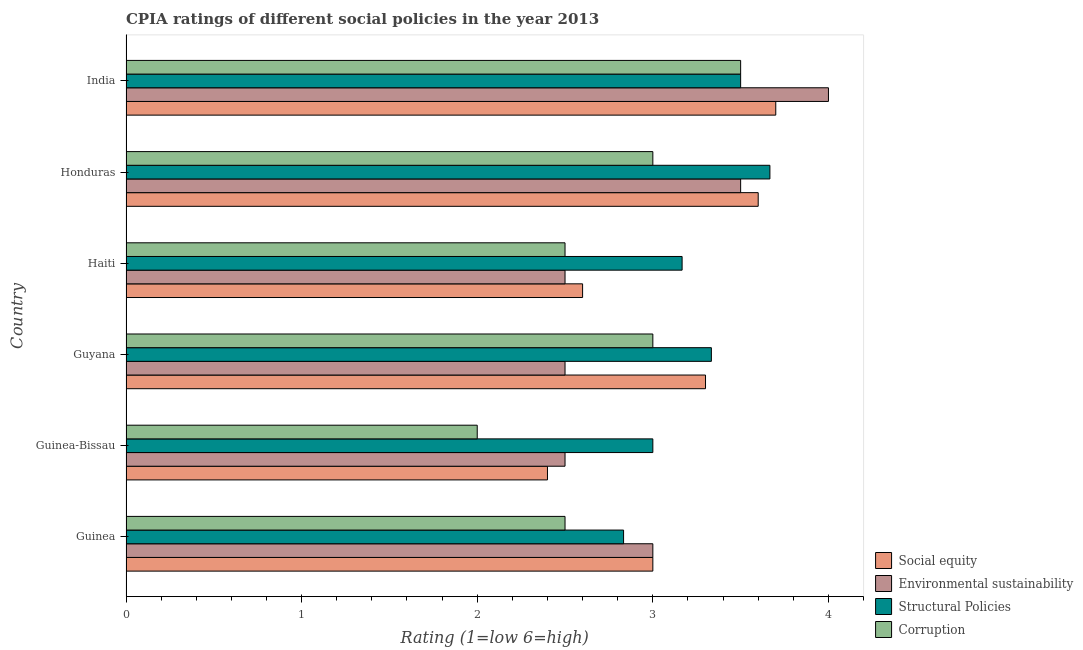How many groups of bars are there?
Offer a terse response. 6. Are the number of bars per tick equal to the number of legend labels?
Provide a short and direct response. Yes. Are the number of bars on each tick of the Y-axis equal?
Provide a short and direct response. Yes. How many bars are there on the 4th tick from the top?
Your answer should be compact. 4. How many bars are there on the 6th tick from the bottom?
Keep it short and to the point. 4. What is the cpia rating of environmental sustainability in Guinea-Bissau?
Your answer should be compact. 2.5. Across all countries, what is the maximum cpia rating of structural policies?
Your answer should be compact. 3.67. Across all countries, what is the minimum cpia rating of social equity?
Offer a very short reply. 2.4. In which country was the cpia rating of environmental sustainability maximum?
Ensure brevity in your answer.  India. In which country was the cpia rating of social equity minimum?
Offer a very short reply. Guinea-Bissau. What is the total cpia rating of social equity in the graph?
Give a very brief answer. 18.6. What is the difference between the cpia rating of structural policies in Haiti and the cpia rating of environmental sustainability in India?
Your answer should be compact. -0.83. What is the average cpia rating of structural policies per country?
Offer a very short reply. 3.25. What is the ratio of the cpia rating of social equity in Guinea to that in Honduras?
Provide a succinct answer. 0.83. Is the cpia rating of social equity in Guyana less than that in Honduras?
Offer a very short reply. Yes. Is the difference between the cpia rating of environmental sustainability in Guinea and India greater than the difference between the cpia rating of structural policies in Guinea and India?
Your answer should be very brief. No. What is the difference between the highest and the second highest cpia rating of social equity?
Offer a very short reply. 0.1. What is the difference between the highest and the lowest cpia rating of corruption?
Make the answer very short. 1.5. What does the 4th bar from the top in Guinea-Bissau represents?
Your answer should be compact. Social equity. What does the 2nd bar from the bottom in Guinea-Bissau represents?
Keep it short and to the point. Environmental sustainability. Is it the case that in every country, the sum of the cpia rating of social equity and cpia rating of environmental sustainability is greater than the cpia rating of structural policies?
Offer a very short reply. Yes. Are all the bars in the graph horizontal?
Provide a succinct answer. Yes. How many countries are there in the graph?
Your response must be concise. 6. Are the values on the major ticks of X-axis written in scientific E-notation?
Provide a short and direct response. No. Does the graph contain grids?
Give a very brief answer. No. Where does the legend appear in the graph?
Keep it short and to the point. Bottom right. How many legend labels are there?
Give a very brief answer. 4. How are the legend labels stacked?
Give a very brief answer. Vertical. What is the title of the graph?
Keep it short and to the point. CPIA ratings of different social policies in the year 2013. Does "UNRWA" appear as one of the legend labels in the graph?
Make the answer very short. No. What is the label or title of the X-axis?
Give a very brief answer. Rating (1=low 6=high). What is the label or title of the Y-axis?
Give a very brief answer. Country. What is the Rating (1=low 6=high) of Environmental sustainability in Guinea?
Provide a short and direct response. 3. What is the Rating (1=low 6=high) of Structural Policies in Guinea?
Offer a very short reply. 2.83. What is the Rating (1=low 6=high) in Social equity in Guinea-Bissau?
Ensure brevity in your answer.  2.4. What is the Rating (1=low 6=high) of Social equity in Guyana?
Give a very brief answer. 3.3. What is the Rating (1=low 6=high) in Environmental sustainability in Guyana?
Provide a succinct answer. 2.5. What is the Rating (1=low 6=high) in Structural Policies in Guyana?
Your answer should be very brief. 3.33. What is the Rating (1=low 6=high) of Structural Policies in Haiti?
Provide a succinct answer. 3.17. What is the Rating (1=low 6=high) of Corruption in Haiti?
Your answer should be compact. 2.5. What is the Rating (1=low 6=high) in Social equity in Honduras?
Make the answer very short. 3.6. What is the Rating (1=low 6=high) in Structural Policies in Honduras?
Your response must be concise. 3.67. What is the Rating (1=low 6=high) in Corruption in Honduras?
Make the answer very short. 3. What is the Rating (1=low 6=high) of Corruption in India?
Your response must be concise. 3.5. Across all countries, what is the maximum Rating (1=low 6=high) in Environmental sustainability?
Make the answer very short. 4. Across all countries, what is the maximum Rating (1=low 6=high) of Structural Policies?
Provide a short and direct response. 3.67. Across all countries, what is the minimum Rating (1=low 6=high) in Environmental sustainability?
Give a very brief answer. 2.5. Across all countries, what is the minimum Rating (1=low 6=high) of Structural Policies?
Your answer should be very brief. 2.83. Across all countries, what is the minimum Rating (1=low 6=high) in Corruption?
Your response must be concise. 2. What is the total Rating (1=low 6=high) in Environmental sustainability in the graph?
Your answer should be compact. 18. What is the total Rating (1=low 6=high) in Structural Policies in the graph?
Your answer should be very brief. 19.5. What is the total Rating (1=low 6=high) of Corruption in the graph?
Keep it short and to the point. 16.5. What is the difference between the Rating (1=low 6=high) of Social equity in Guinea and that in Guinea-Bissau?
Provide a succinct answer. 0.6. What is the difference between the Rating (1=low 6=high) in Social equity in Guinea and that in Guyana?
Ensure brevity in your answer.  -0.3. What is the difference between the Rating (1=low 6=high) in Structural Policies in Guinea and that in Guyana?
Provide a short and direct response. -0.5. What is the difference between the Rating (1=low 6=high) of Corruption in Guinea and that in Guyana?
Your answer should be very brief. -0.5. What is the difference between the Rating (1=low 6=high) of Social equity in Guinea and that in Haiti?
Your answer should be very brief. 0.4. What is the difference between the Rating (1=low 6=high) of Environmental sustainability in Guinea and that in Haiti?
Keep it short and to the point. 0.5. What is the difference between the Rating (1=low 6=high) in Structural Policies in Guinea and that in Haiti?
Your response must be concise. -0.33. What is the difference between the Rating (1=low 6=high) in Corruption in Guinea and that in Haiti?
Your answer should be compact. 0. What is the difference between the Rating (1=low 6=high) of Social equity in Guinea and that in India?
Provide a succinct answer. -0.7. What is the difference between the Rating (1=low 6=high) of Environmental sustainability in Guinea and that in India?
Provide a short and direct response. -1. What is the difference between the Rating (1=low 6=high) of Social equity in Guinea-Bissau and that in Guyana?
Provide a succinct answer. -0.9. What is the difference between the Rating (1=low 6=high) in Environmental sustainability in Guinea-Bissau and that in Guyana?
Provide a short and direct response. 0. What is the difference between the Rating (1=low 6=high) of Corruption in Guinea-Bissau and that in Guyana?
Your answer should be very brief. -1. What is the difference between the Rating (1=low 6=high) of Social equity in Guinea-Bissau and that in Haiti?
Offer a very short reply. -0.2. What is the difference between the Rating (1=low 6=high) of Environmental sustainability in Guinea-Bissau and that in Haiti?
Provide a succinct answer. 0. What is the difference between the Rating (1=low 6=high) in Corruption in Guinea-Bissau and that in Haiti?
Your answer should be very brief. -0.5. What is the difference between the Rating (1=low 6=high) of Environmental sustainability in Guinea-Bissau and that in Honduras?
Your response must be concise. -1. What is the difference between the Rating (1=low 6=high) in Structural Policies in Guinea-Bissau and that in Honduras?
Give a very brief answer. -0.67. What is the difference between the Rating (1=low 6=high) of Corruption in Guinea-Bissau and that in Honduras?
Provide a succinct answer. -1. What is the difference between the Rating (1=low 6=high) of Structural Policies in Guinea-Bissau and that in India?
Your response must be concise. -0.5. What is the difference between the Rating (1=low 6=high) of Social equity in Guyana and that in Haiti?
Give a very brief answer. 0.7. What is the difference between the Rating (1=low 6=high) of Structural Policies in Guyana and that in Haiti?
Provide a succinct answer. 0.17. What is the difference between the Rating (1=low 6=high) in Social equity in Guyana and that in Honduras?
Provide a short and direct response. -0.3. What is the difference between the Rating (1=low 6=high) of Environmental sustainability in Guyana and that in Honduras?
Provide a succinct answer. -1. What is the difference between the Rating (1=low 6=high) in Structural Policies in Guyana and that in Honduras?
Give a very brief answer. -0.33. What is the difference between the Rating (1=low 6=high) in Corruption in Guyana and that in Honduras?
Offer a very short reply. 0. What is the difference between the Rating (1=low 6=high) in Environmental sustainability in Guyana and that in India?
Ensure brevity in your answer.  -1.5. What is the difference between the Rating (1=low 6=high) in Structural Policies in Guyana and that in India?
Your response must be concise. -0.17. What is the difference between the Rating (1=low 6=high) in Corruption in Guyana and that in India?
Ensure brevity in your answer.  -0.5. What is the difference between the Rating (1=low 6=high) in Corruption in Haiti and that in Honduras?
Your answer should be very brief. -0.5. What is the difference between the Rating (1=low 6=high) in Social equity in Haiti and that in India?
Provide a succinct answer. -1.1. What is the difference between the Rating (1=low 6=high) of Structural Policies in Haiti and that in India?
Offer a terse response. -0.33. What is the difference between the Rating (1=low 6=high) in Corruption in Haiti and that in India?
Your response must be concise. -1. What is the difference between the Rating (1=low 6=high) of Social equity in Guinea and the Rating (1=low 6=high) of Environmental sustainability in Guinea-Bissau?
Ensure brevity in your answer.  0.5. What is the difference between the Rating (1=low 6=high) in Environmental sustainability in Guinea and the Rating (1=low 6=high) in Structural Policies in Guinea-Bissau?
Offer a terse response. 0. What is the difference between the Rating (1=low 6=high) of Structural Policies in Guinea and the Rating (1=low 6=high) of Corruption in Guinea-Bissau?
Keep it short and to the point. 0.83. What is the difference between the Rating (1=low 6=high) of Social equity in Guinea and the Rating (1=low 6=high) of Structural Policies in Guyana?
Ensure brevity in your answer.  -0.33. What is the difference between the Rating (1=low 6=high) of Social equity in Guinea and the Rating (1=low 6=high) of Corruption in Guyana?
Offer a very short reply. 0. What is the difference between the Rating (1=low 6=high) in Environmental sustainability in Guinea and the Rating (1=low 6=high) in Corruption in Guyana?
Offer a terse response. 0. What is the difference between the Rating (1=low 6=high) of Social equity in Guinea and the Rating (1=low 6=high) of Structural Policies in Haiti?
Offer a terse response. -0.17. What is the difference between the Rating (1=low 6=high) of Social equity in Guinea and the Rating (1=low 6=high) of Corruption in Haiti?
Offer a terse response. 0.5. What is the difference between the Rating (1=low 6=high) of Environmental sustainability in Guinea and the Rating (1=low 6=high) of Corruption in Haiti?
Your response must be concise. 0.5. What is the difference between the Rating (1=low 6=high) of Social equity in Guinea and the Rating (1=low 6=high) of Environmental sustainability in Honduras?
Give a very brief answer. -0.5. What is the difference between the Rating (1=low 6=high) of Social equity in Guinea and the Rating (1=low 6=high) of Structural Policies in India?
Your answer should be very brief. -0.5. What is the difference between the Rating (1=low 6=high) of Social equity in Guinea and the Rating (1=low 6=high) of Corruption in India?
Keep it short and to the point. -0.5. What is the difference between the Rating (1=low 6=high) in Environmental sustainability in Guinea and the Rating (1=low 6=high) in Structural Policies in India?
Your answer should be very brief. -0.5. What is the difference between the Rating (1=low 6=high) of Environmental sustainability in Guinea and the Rating (1=low 6=high) of Corruption in India?
Provide a short and direct response. -0.5. What is the difference between the Rating (1=low 6=high) in Social equity in Guinea-Bissau and the Rating (1=low 6=high) in Structural Policies in Guyana?
Give a very brief answer. -0.93. What is the difference between the Rating (1=low 6=high) of Social equity in Guinea-Bissau and the Rating (1=low 6=high) of Corruption in Guyana?
Make the answer very short. -0.6. What is the difference between the Rating (1=low 6=high) of Environmental sustainability in Guinea-Bissau and the Rating (1=low 6=high) of Corruption in Guyana?
Your answer should be compact. -0.5. What is the difference between the Rating (1=low 6=high) of Structural Policies in Guinea-Bissau and the Rating (1=low 6=high) of Corruption in Guyana?
Your response must be concise. 0. What is the difference between the Rating (1=low 6=high) of Social equity in Guinea-Bissau and the Rating (1=low 6=high) of Structural Policies in Haiti?
Your response must be concise. -0.77. What is the difference between the Rating (1=low 6=high) of Social equity in Guinea-Bissau and the Rating (1=low 6=high) of Corruption in Haiti?
Provide a short and direct response. -0.1. What is the difference between the Rating (1=low 6=high) in Environmental sustainability in Guinea-Bissau and the Rating (1=low 6=high) in Structural Policies in Haiti?
Keep it short and to the point. -0.67. What is the difference between the Rating (1=low 6=high) in Environmental sustainability in Guinea-Bissau and the Rating (1=low 6=high) in Corruption in Haiti?
Provide a succinct answer. 0. What is the difference between the Rating (1=low 6=high) of Structural Policies in Guinea-Bissau and the Rating (1=low 6=high) of Corruption in Haiti?
Offer a very short reply. 0.5. What is the difference between the Rating (1=low 6=high) of Social equity in Guinea-Bissau and the Rating (1=low 6=high) of Environmental sustainability in Honduras?
Keep it short and to the point. -1.1. What is the difference between the Rating (1=low 6=high) of Social equity in Guinea-Bissau and the Rating (1=low 6=high) of Structural Policies in Honduras?
Your answer should be very brief. -1.27. What is the difference between the Rating (1=low 6=high) of Social equity in Guinea-Bissau and the Rating (1=low 6=high) of Corruption in Honduras?
Ensure brevity in your answer.  -0.6. What is the difference between the Rating (1=low 6=high) in Environmental sustainability in Guinea-Bissau and the Rating (1=low 6=high) in Structural Policies in Honduras?
Provide a short and direct response. -1.17. What is the difference between the Rating (1=low 6=high) of Environmental sustainability in Guinea-Bissau and the Rating (1=low 6=high) of Corruption in Honduras?
Your answer should be very brief. -0.5. What is the difference between the Rating (1=low 6=high) in Structural Policies in Guinea-Bissau and the Rating (1=low 6=high) in Corruption in Honduras?
Ensure brevity in your answer.  0. What is the difference between the Rating (1=low 6=high) in Social equity in Guinea-Bissau and the Rating (1=low 6=high) in Corruption in India?
Offer a terse response. -1.1. What is the difference between the Rating (1=low 6=high) in Environmental sustainability in Guinea-Bissau and the Rating (1=low 6=high) in Structural Policies in India?
Make the answer very short. -1. What is the difference between the Rating (1=low 6=high) in Structural Policies in Guinea-Bissau and the Rating (1=low 6=high) in Corruption in India?
Provide a short and direct response. -0.5. What is the difference between the Rating (1=low 6=high) of Social equity in Guyana and the Rating (1=low 6=high) of Structural Policies in Haiti?
Provide a succinct answer. 0.13. What is the difference between the Rating (1=low 6=high) of Environmental sustainability in Guyana and the Rating (1=low 6=high) of Structural Policies in Haiti?
Offer a terse response. -0.67. What is the difference between the Rating (1=low 6=high) of Structural Policies in Guyana and the Rating (1=low 6=high) of Corruption in Haiti?
Provide a succinct answer. 0.83. What is the difference between the Rating (1=low 6=high) of Social equity in Guyana and the Rating (1=low 6=high) of Environmental sustainability in Honduras?
Offer a terse response. -0.2. What is the difference between the Rating (1=low 6=high) in Social equity in Guyana and the Rating (1=low 6=high) in Structural Policies in Honduras?
Your answer should be compact. -0.37. What is the difference between the Rating (1=low 6=high) in Environmental sustainability in Guyana and the Rating (1=low 6=high) in Structural Policies in Honduras?
Keep it short and to the point. -1.17. What is the difference between the Rating (1=low 6=high) in Structural Policies in Guyana and the Rating (1=low 6=high) in Corruption in Honduras?
Give a very brief answer. 0.33. What is the difference between the Rating (1=low 6=high) in Social equity in Guyana and the Rating (1=low 6=high) in Corruption in India?
Give a very brief answer. -0.2. What is the difference between the Rating (1=low 6=high) of Social equity in Haiti and the Rating (1=low 6=high) of Structural Policies in Honduras?
Your answer should be compact. -1.07. What is the difference between the Rating (1=low 6=high) of Social equity in Haiti and the Rating (1=low 6=high) of Corruption in Honduras?
Give a very brief answer. -0.4. What is the difference between the Rating (1=low 6=high) of Environmental sustainability in Haiti and the Rating (1=low 6=high) of Structural Policies in Honduras?
Your answer should be compact. -1.17. What is the difference between the Rating (1=low 6=high) of Social equity in Haiti and the Rating (1=low 6=high) of Structural Policies in India?
Keep it short and to the point. -0.9. What is the difference between the Rating (1=low 6=high) of Social equity in Haiti and the Rating (1=low 6=high) of Corruption in India?
Offer a very short reply. -0.9. What is the difference between the Rating (1=low 6=high) in Environmental sustainability in Haiti and the Rating (1=low 6=high) in Structural Policies in India?
Ensure brevity in your answer.  -1. What is the difference between the Rating (1=low 6=high) in Environmental sustainability in Haiti and the Rating (1=low 6=high) in Corruption in India?
Make the answer very short. -1. What is the difference between the Rating (1=low 6=high) in Structural Policies in Haiti and the Rating (1=low 6=high) in Corruption in India?
Provide a succinct answer. -0.33. What is the difference between the Rating (1=low 6=high) of Social equity in Honduras and the Rating (1=low 6=high) of Environmental sustainability in India?
Your answer should be very brief. -0.4. What is the difference between the Rating (1=low 6=high) in Social equity in Honduras and the Rating (1=low 6=high) in Corruption in India?
Give a very brief answer. 0.1. What is the difference between the Rating (1=low 6=high) in Environmental sustainability in Honduras and the Rating (1=low 6=high) in Corruption in India?
Provide a succinct answer. 0. What is the average Rating (1=low 6=high) of Social equity per country?
Give a very brief answer. 3.1. What is the average Rating (1=low 6=high) in Environmental sustainability per country?
Provide a short and direct response. 3. What is the average Rating (1=low 6=high) of Corruption per country?
Provide a short and direct response. 2.75. What is the difference between the Rating (1=low 6=high) of Social equity and Rating (1=low 6=high) of Corruption in Guinea?
Ensure brevity in your answer.  0.5. What is the difference between the Rating (1=low 6=high) in Social equity and Rating (1=low 6=high) in Structural Policies in Guinea-Bissau?
Ensure brevity in your answer.  -0.6. What is the difference between the Rating (1=low 6=high) of Social equity and Rating (1=low 6=high) of Corruption in Guinea-Bissau?
Provide a succinct answer. 0.4. What is the difference between the Rating (1=low 6=high) of Environmental sustainability and Rating (1=low 6=high) of Structural Policies in Guinea-Bissau?
Offer a very short reply. -0.5. What is the difference between the Rating (1=low 6=high) of Environmental sustainability and Rating (1=low 6=high) of Corruption in Guinea-Bissau?
Ensure brevity in your answer.  0.5. What is the difference between the Rating (1=low 6=high) in Structural Policies and Rating (1=low 6=high) in Corruption in Guinea-Bissau?
Your answer should be very brief. 1. What is the difference between the Rating (1=low 6=high) in Social equity and Rating (1=low 6=high) in Structural Policies in Guyana?
Make the answer very short. -0.03. What is the difference between the Rating (1=low 6=high) in Social equity and Rating (1=low 6=high) in Corruption in Guyana?
Keep it short and to the point. 0.3. What is the difference between the Rating (1=low 6=high) in Environmental sustainability and Rating (1=low 6=high) in Corruption in Guyana?
Keep it short and to the point. -0.5. What is the difference between the Rating (1=low 6=high) in Structural Policies and Rating (1=low 6=high) in Corruption in Guyana?
Your response must be concise. 0.33. What is the difference between the Rating (1=low 6=high) of Social equity and Rating (1=low 6=high) of Environmental sustainability in Haiti?
Ensure brevity in your answer.  0.1. What is the difference between the Rating (1=low 6=high) of Social equity and Rating (1=low 6=high) of Structural Policies in Haiti?
Provide a succinct answer. -0.57. What is the difference between the Rating (1=low 6=high) in Environmental sustainability and Rating (1=low 6=high) in Structural Policies in Haiti?
Provide a succinct answer. -0.67. What is the difference between the Rating (1=low 6=high) of Social equity and Rating (1=low 6=high) of Environmental sustainability in Honduras?
Your answer should be very brief. 0.1. What is the difference between the Rating (1=low 6=high) in Social equity and Rating (1=low 6=high) in Structural Policies in Honduras?
Give a very brief answer. -0.07. What is the difference between the Rating (1=low 6=high) in Social equity and Rating (1=low 6=high) in Corruption in Honduras?
Keep it short and to the point. 0.6. What is the difference between the Rating (1=low 6=high) of Structural Policies and Rating (1=low 6=high) of Corruption in Honduras?
Offer a terse response. 0.67. What is the difference between the Rating (1=low 6=high) of Social equity and Rating (1=low 6=high) of Environmental sustainability in India?
Give a very brief answer. -0.3. What is the difference between the Rating (1=low 6=high) of Social equity and Rating (1=low 6=high) of Structural Policies in India?
Offer a very short reply. 0.2. What is the difference between the Rating (1=low 6=high) of Social equity and Rating (1=low 6=high) of Corruption in India?
Offer a terse response. 0.2. What is the difference between the Rating (1=low 6=high) in Environmental sustainability and Rating (1=low 6=high) in Structural Policies in India?
Offer a very short reply. 0.5. What is the difference between the Rating (1=low 6=high) in Environmental sustainability and Rating (1=low 6=high) in Corruption in India?
Your response must be concise. 0.5. What is the ratio of the Rating (1=low 6=high) in Environmental sustainability in Guinea to that in Guyana?
Make the answer very short. 1.2. What is the ratio of the Rating (1=low 6=high) of Social equity in Guinea to that in Haiti?
Offer a very short reply. 1.15. What is the ratio of the Rating (1=low 6=high) of Environmental sustainability in Guinea to that in Haiti?
Your answer should be very brief. 1.2. What is the ratio of the Rating (1=low 6=high) of Structural Policies in Guinea to that in Haiti?
Give a very brief answer. 0.89. What is the ratio of the Rating (1=low 6=high) of Corruption in Guinea to that in Haiti?
Your answer should be very brief. 1. What is the ratio of the Rating (1=low 6=high) in Structural Policies in Guinea to that in Honduras?
Provide a succinct answer. 0.77. What is the ratio of the Rating (1=low 6=high) in Corruption in Guinea to that in Honduras?
Make the answer very short. 0.83. What is the ratio of the Rating (1=low 6=high) in Social equity in Guinea to that in India?
Keep it short and to the point. 0.81. What is the ratio of the Rating (1=low 6=high) in Environmental sustainability in Guinea to that in India?
Make the answer very short. 0.75. What is the ratio of the Rating (1=low 6=high) of Structural Policies in Guinea to that in India?
Offer a terse response. 0.81. What is the ratio of the Rating (1=low 6=high) of Corruption in Guinea to that in India?
Keep it short and to the point. 0.71. What is the ratio of the Rating (1=low 6=high) of Social equity in Guinea-Bissau to that in Guyana?
Ensure brevity in your answer.  0.73. What is the ratio of the Rating (1=low 6=high) in Environmental sustainability in Guinea-Bissau to that in Guyana?
Offer a terse response. 1. What is the ratio of the Rating (1=low 6=high) in Social equity in Guinea-Bissau to that in Honduras?
Make the answer very short. 0.67. What is the ratio of the Rating (1=low 6=high) of Structural Policies in Guinea-Bissau to that in Honduras?
Provide a succinct answer. 0.82. What is the ratio of the Rating (1=low 6=high) in Corruption in Guinea-Bissau to that in Honduras?
Provide a short and direct response. 0.67. What is the ratio of the Rating (1=low 6=high) of Social equity in Guinea-Bissau to that in India?
Offer a very short reply. 0.65. What is the ratio of the Rating (1=low 6=high) of Social equity in Guyana to that in Haiti?
Keep it short and to the point. 1.27. What is the ratio of the Rating (1=low 6=high) in Structural Policies in Guyana to that in Haiti?
Give a very brief answer. 1.05. What is the ratio of the Rating (1=low 6=high) in Environmental sustainability in Guyana to that in Honduras?
Provide a succinct answer. 0.71. What is the ratio of the Rating (1=low 6=high) of Social equity in Guyana to that in India?
Your response must be concise. 0.89. What is the ratio of the Rating (1=low 6=high) of Social equity in Haiti to that in Honduras?
Make the answer very short. 0.72. What is the ratio of the Rating (1=low 6=high) in Environmental sustainability in Haiti to that in Honduras?
Your answer should be very brief. 0.71. What is the ratio of the Rating (1=low 6=high) of Structural Policies in Haiti to that in Honduras?
Give a very brief answer. 0.86. What is the ratio of the Rating (1=low 6=high) in Social equity in Haiti to that in India?
Make the answer very short. 0.7. What is the ratio of the Rating (1=low 6=high) in Structural Policies in Haiti to that in India?
Your answer should be compact. 0.9. What is the ratio of the Rating (1=low 6=high) of Corruption in Haiti to that in India?
Provide a succinct answer. 0.71. What is the ratio of the Rating (1=low 6=high) in Structural Policies in Honduras to that in India?
Your answer should be compact. 1.05. What is the ratio of the Rating (1=low 6=high) of Corruption in Honduras to that in India?
Provide a succinct answer. 0.86. What is the difference between the highest and the second highest Rating (1=low 6=high) in Social equity?
Offer a terse response. 0.1. What is the difference between the highest and the second highest Rating (1=low 6=high) in Environmental sustainability?
Your response must be concise. 0.5. What is the difference between the highest and the second highest Rating (1=low 6=high) in Structural Policies?
Make the answer very short. 0.17. What is the difference between the highest and the lowest Rating (1=low 6=high) in Environmental sustainability?
Offer a very short reply. 1.5. What is the difference between the highest and the lowest Rating (1=low 6=high) in Structural Policies?
Your answer should be compact. 0.83. What is the difference between the highest and the lowest Rating (1=low 6=high) in Corruption?
Give a very brief answer. 1.5. 